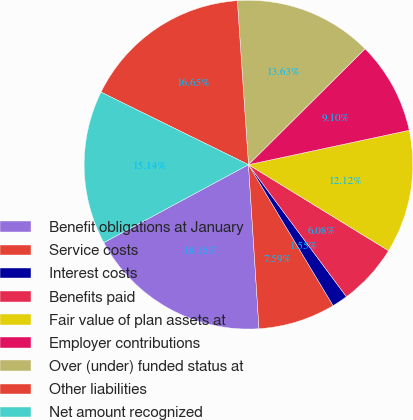Convert chart to OTSL. <chart><loc_0><loc_0><loc_500><loc_500><pie_chart><fcel>Benefit obligations at January<fcel>Service costs<fcel>Interest costs<fcel>Benefits paid<fcel>Fair value of plan assets at<fcel>Employer contributions<fcel>Over (under) funded status at<fcel>Other liabilities<fcel>Net amount recognized<nl><fcel>18.16%<fcel>7.59%<fcel>1.55%<fcel>6.08%<fcel>12.12%<fcel>9.1%<fcel>13.63%<fcel>16.65%<fcel>15.14%<nl></chart> 